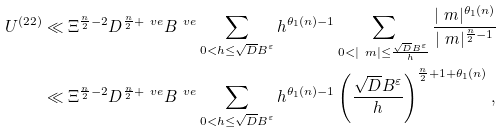Convert formula to latex. <formula><loc_0><loc_0><loc_500><loc_500>U ^ { ( 2 2 ) } & \ll \Xi ^ { \frac { n } { 2 } - 2 } D ^ { \frac { n } { 2 } + \ v e } B ^ { \ v e } \sum _ { \substack { 0 < h \leq \sqrt { D } B ^ { \varepsilon } } } h ^ { \theta _ { 1 } ( n ) - 1 } \sum _ { \substack { 0 < | \ m | \leq \frac { \sqrt { D } B ^ { \varepsilon } } { h } } } \frac { | \ m | ^ { \theta _ { 1 } ( n ) } } { | \ m | ^ { \frac { n } { 2 } - 1 } } \\ & \ll \Xi ^ { \frac { n } { 2 } - 2 } D ^ { \frac { n } { 2 } + \ v e } B ^ { \ v e } \sum _ { \substack { 0 < h \leq \sqrt { D } B ^ { \varepsilon } } } h ^ { \theta _ { 1 } ( n ) - 1 } \left ( \frac { \sqrt { D } B ^ { \varepsilon } } { h } \right ) ^ { \frac { n } { 2 } + 1 + \theta _ { 1 } ( n ) } ,</formula> 